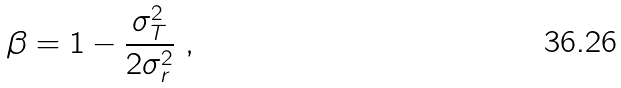Convert formula to latex. <formula><loc_0><loc_0><loc_500><loc_500>\beta = 1 - \frac { \sigma _ { T } ^ { 2 } } { 2 \sigma _ { r } ^ { 2 } } \ ,</formula> 